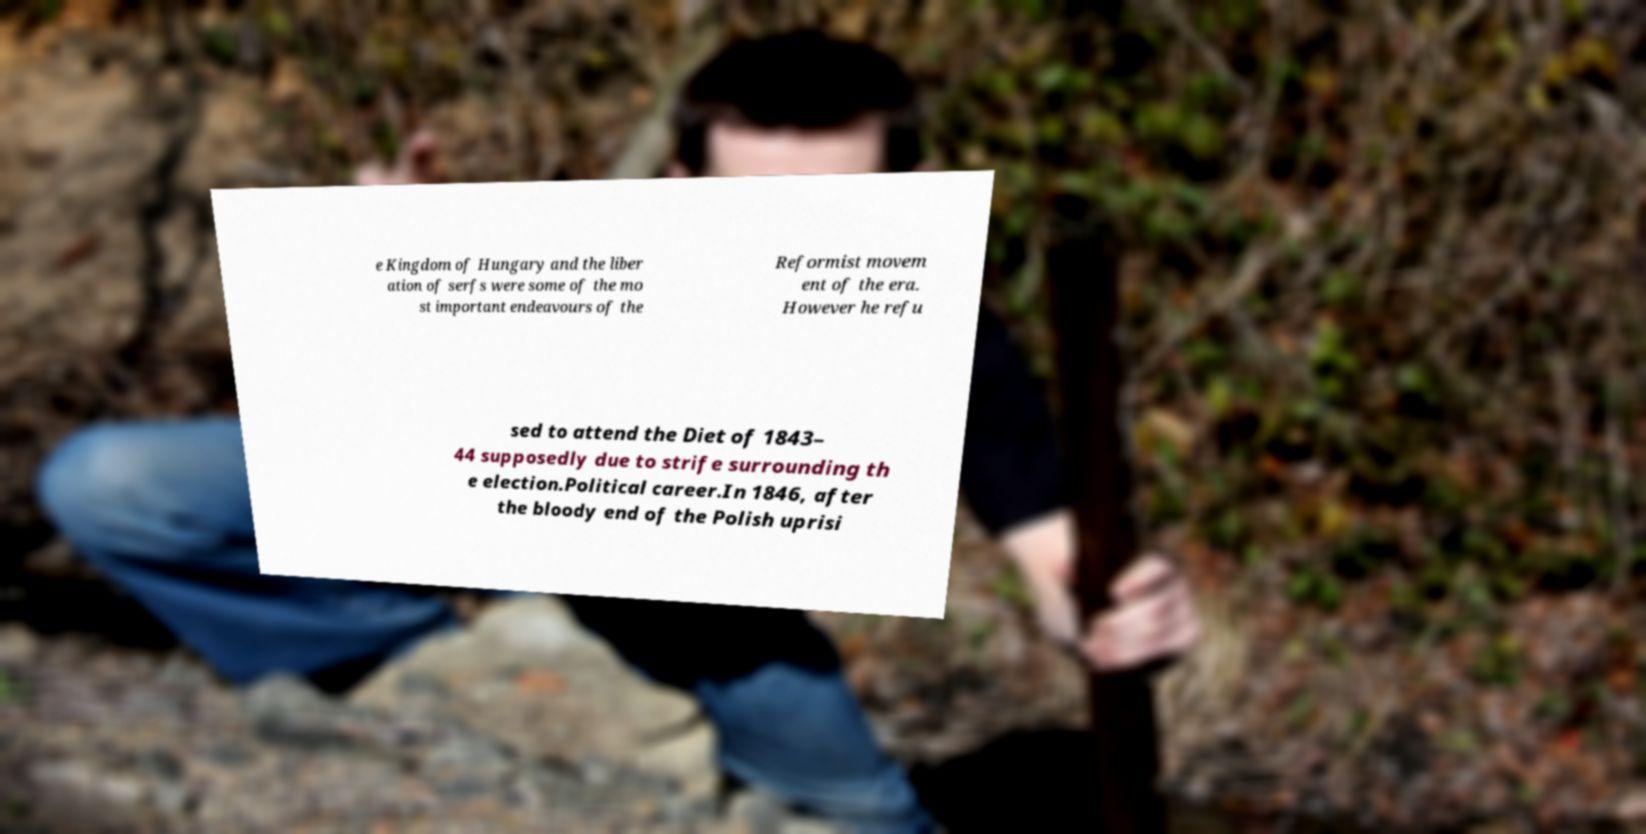Could you assist in decoding the text presented in this image and type it out clearly? e Kingdom of Hungary and the liber ation of serfs were some of the mo st important endeavours of the Reformist movem ent of the era. However he refu sed to attend the Diet of 1843– 44 supposedly due to strife surrounding th e election.Political career.In 1846, after the bloody end of the Polish uprisi 